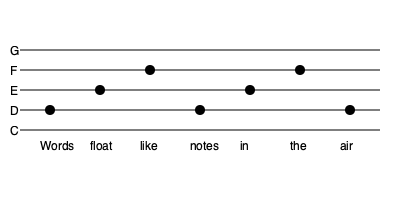Analyze the rhythm pattern represented in the musical notation above and determine its corresponding poetic meter. How does this rhythm enhance the meaning of the phrase "Words float like notes in the air"? To analyze the rhythm pattern and determine the poetic meter, we'll follow these steps:

1. Identify the note pattern:
   The notes follow a D-E-F-D-E-F-D pattern.

2. Determine the rhythm:
   The rhythm is consistent, with each note receiving equal emphasis.

3. Count the syllables:
   "Words float like notes in the air" has 7 syllables.

4. Match syllables to notes:
   Each syllable corresponds to one note in the musical notation.

5. Analyze stress pattern:
   The stress pattern is:
   STRESSED - unstressed - STRESSED - unstressed - STRESSED - unstressed - STRESSED

6. Identify the poetic meter:
   This pattern of alternating stressed and unstressed syllables in groups of two is known as trochaic tetrameter, with the last foot truncated (catalectic).

7. Interpret the rhythm's effect:
   The trochaic rhythm mimics the gentle rise and fall of floating objects, reinforcing the imagery of words floating like musical notes. The alternating high and low notes in the melody further emphasize this floating quality.

8. Analyze the connection between rhythm and meaning:
   The regular, wave-like rhythm enhances the sense of words effortlessly moving through space, much like musical notes. This rhythm creates a melodic quality in the spoken word, blending the concepts of poetry and music.

9. Consider the persona's perspective:
   As a spoken word poet influenced by musical melodies, this rhythm demonstrates how musical notation can inform the cadence and delivery of poetry, creating a symbiosis between the two art forms.
Answer: Trochaic tetrameter (catalectic); enhances floating imagery and melodic quality 